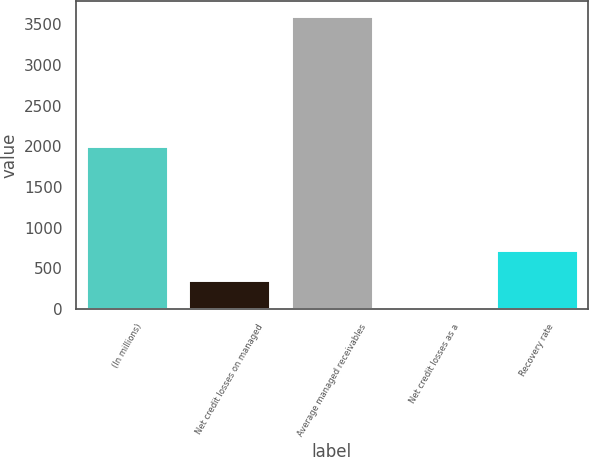<chart> <loc_0><loc_0><loc_500><loc_500><bar_chart><fcel>(In millions)<fcel>Net credit losses on managed<fcel>Average managed receivables<fcel>Net credit losses as a<fcel>Recovery rate<nl><fcel>2008<fcel>361.79<fcel>3608.4<fcel>1.06<fcel>722.52<nl></chart> 